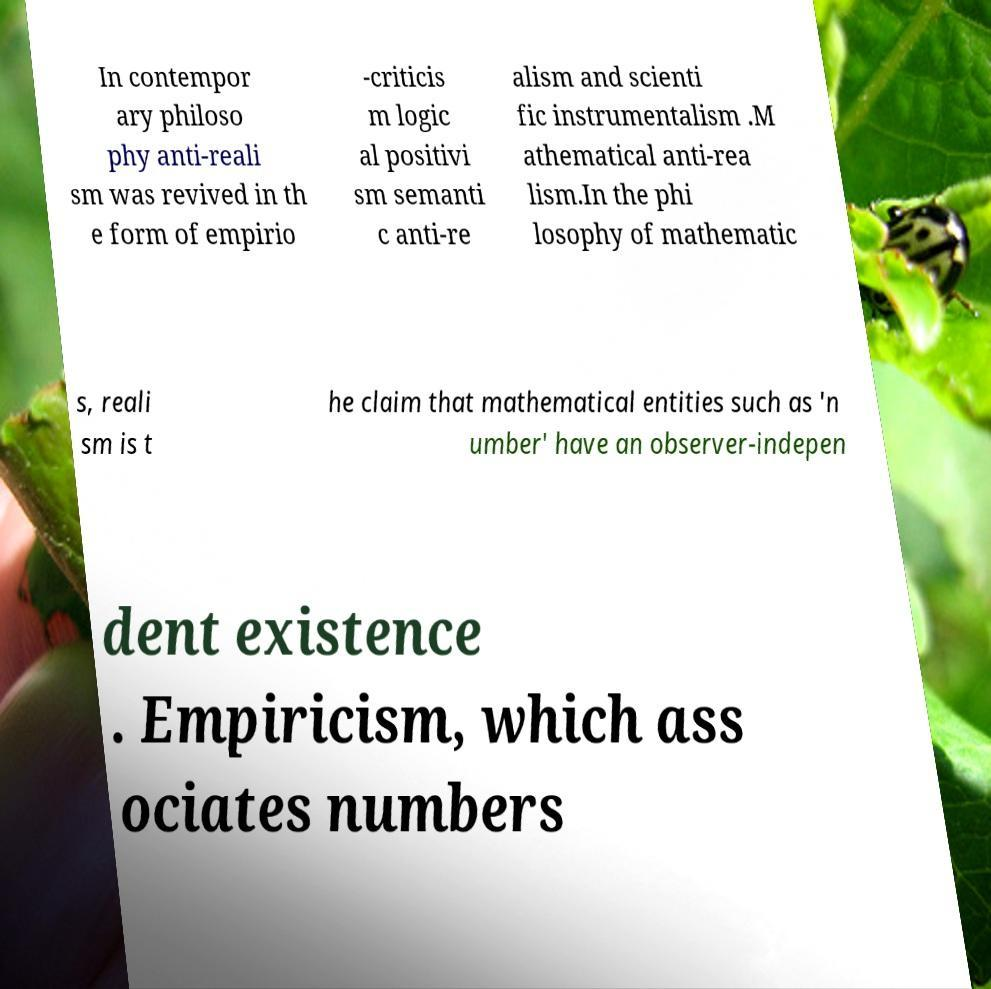For documentation purposes, I need the text within this image transcribed. Could you provide that? In contempor ary philoso phy anti-reali sm was revived in th e form of empirio -criticis m logic al positivi sm semanti c anti-re alism and scienti fic instrumentalism .M athematical anti-rea lism.In the phi losophy of mathematic s, reali sm is t he claim that mathematical entities such as 'n umber' have an observer-indepen dent existence . Empiricism, which ass ociates numbers 